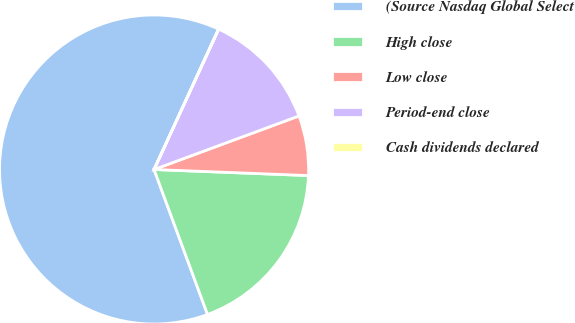Convert chart to OTSL. <chart><loc_0><loc_0><loc_500><loc_500><pie_chart><fcel>(Source Nasdaq Global Select<fcel>High close<fcel>Low close<fcel>Period-end close<fcel>Cash dividends declared<nl><fcel>62.48%<fcel>18.75%<fcel>6.26%<fcel>12.5%<fcel>0.01%<nl></chart> 